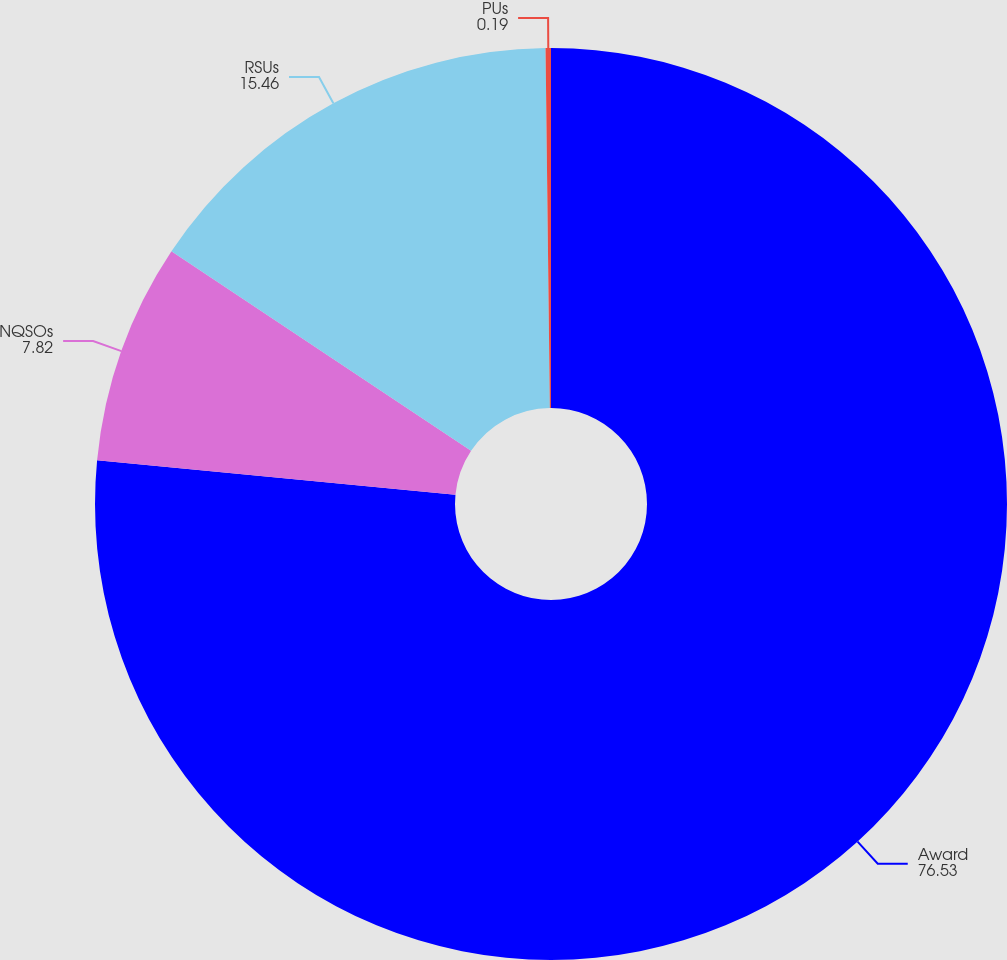<chart> <loc_0><loc_0><loc_500><loc_500><pie_chart><fcel>Award<fcel>NQSOs<fcel>RSUs<fcel>PUs<nl><fcel>76.53%<fcel>7.82%<fcel>15.46%<fcel>0.19%<nl></chart> 